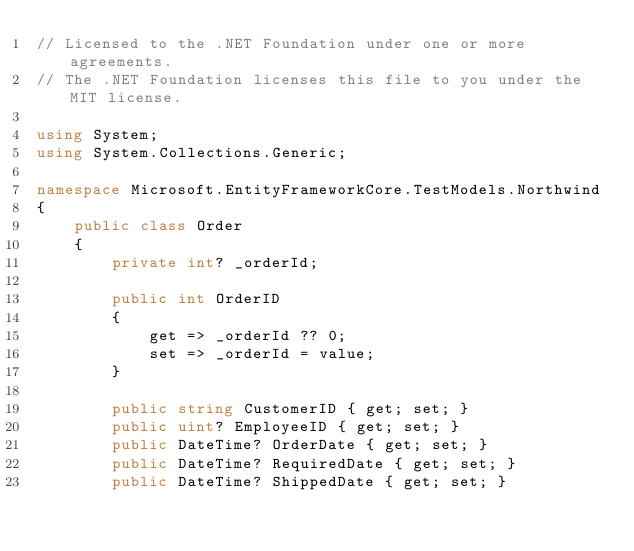Convert code to text. <code><loc_0><loc_0><loc_500><loc_500><_C#_>// Licensed to the .NET Foundation under one or more agreements.
// The .NET Foundation licenses this file to you under the MIT license.

using System;
using System.Collections.Generic;

namespace Microsoft.EntityFrameworkCore.TestModels.Northwind
{
    public class Order
    {
        private int? _orderId;

        public int OrderID
        {
            get => _orderId ?? 0;
            set => _orderId = value;
        }

        public string CustomerID { get; set; }
        public uint? EmployeeID { get; set; }
        public DateTime? OrderDate { get; set; }
        public DateTime? RequiredDate { get; set; }
        public DateTime? ShippedDate { get; set; }</code> 